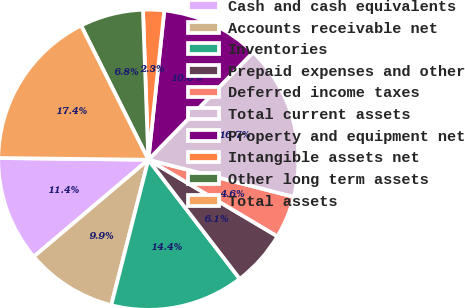Convert chart. <chart><loc_0><loc_0><loc_500><loc_500><pie_chart><fcel>Cash and cash equivalents<fcel>Accounts receivable net<fcel>Inventories<fcel>Prepaid expenses and other<fcel>Deferred income taxes<fcel>Total current assets<fcel>Property and equipment net<fcel>Intangible assets net<fcel>Other long term assets<fcel>Total assets<nl><fcel>11.36%<fcel>9.85%<fcel>14.39%<fcel>6.06%<fcel>4.55%<fcel>16.67%<fcel>10.61%<fcel>2.27%<fcel>6.82%<fcel>17.42%<nl></chart> 